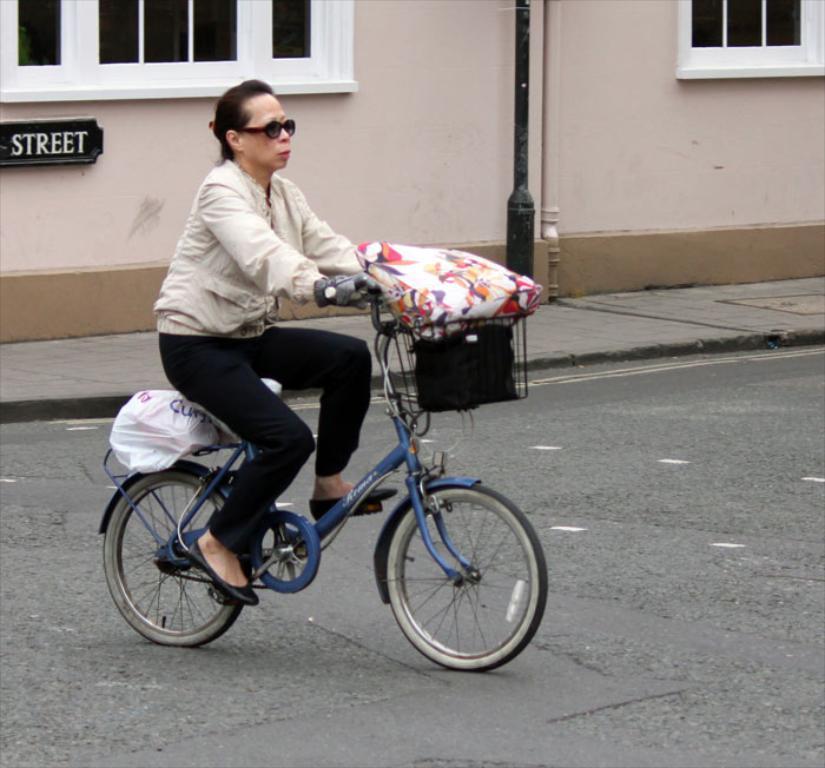In one or two sentences, can you explain what this image depicts? In this image I can see a woman is doing cycling on the road. I can see the woman is wearing glasses, gloves. On the cycle we have a basket, bag and other objects on it. In the background I can see there is a building and a pole. 